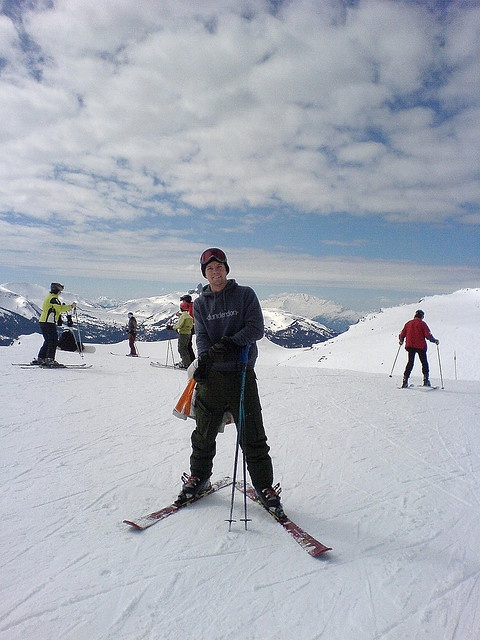Describe the objects in this image and their specific colors. I can see people in darkgray, black, gray, and lightgray tones, skis in darkgray, gray, black, and lightgray tones, people in darkgray, maroon, black, lightgray, and navy tones, people in darkgray, black, olive, and gray tones, and people in darkgray, black, darkgreen, and gray tones in this image. 